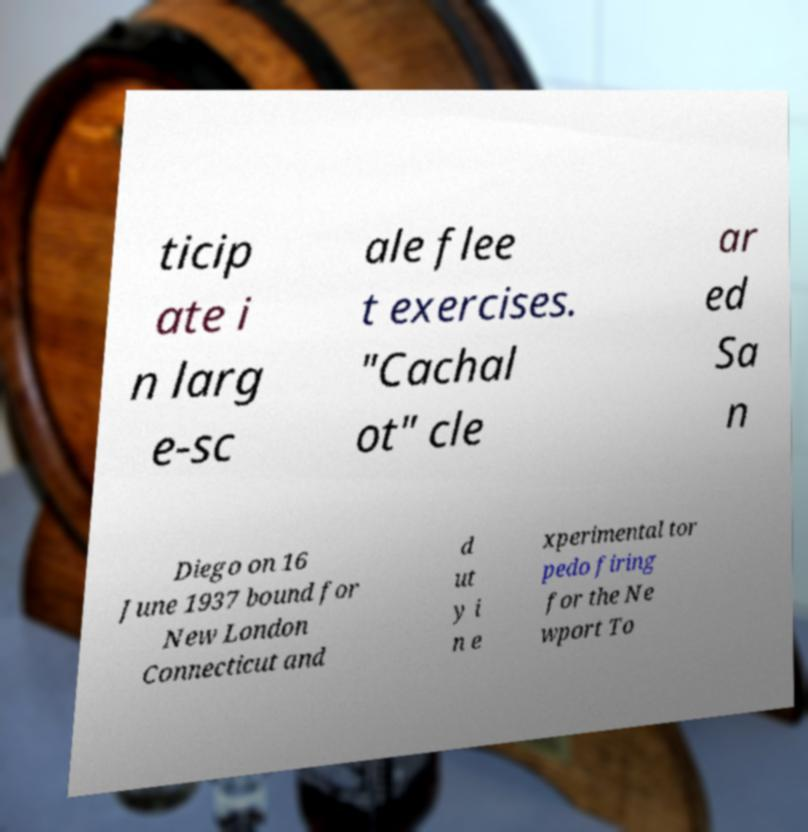For documentation purposes, I need the text within this image transcribed. Could you provide that? ticip ate i n larg e-sc ale flee t exercises. "Cachal ot" cle ar ed Sa n Diego on 16 June 1937 bound for New London Connecticut and d ut y i n e xperimental tor pedo firing for the Ne wport To 